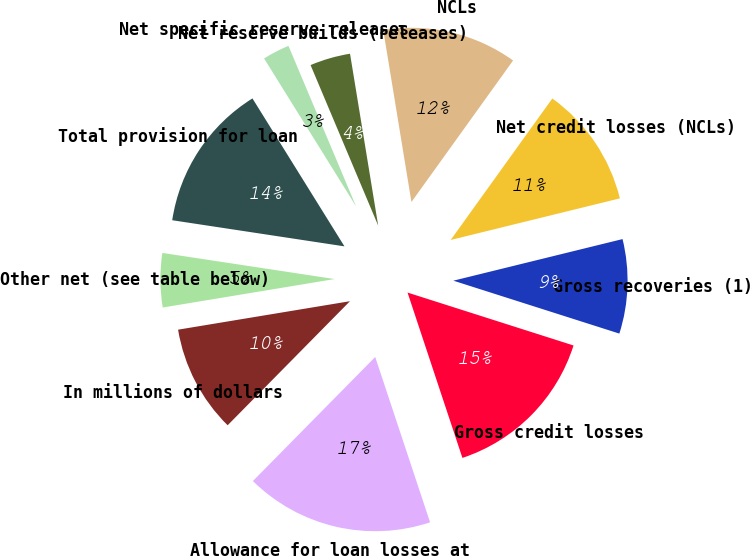<chart> <loc_0><loc_0><loc_500><loc_500><pie_chart><fcel>In millions of dollars<fcel>Allowance for loan losses at<fcel>Gross credit losses<fcel>Gross recoveries (1)<fcel>Net credit losses (NCLs)<fcel>NCLs<fcel>Net reserve builds (releases)<fcel>Net specific reserve releases<fcel>Total provision for loan<fcel>Other net (see table below)<nl><fcel>10.0%<fcel>17.49%<fcel>14.99%<fcel>8.75%<fcel>11.25%<fcel>12.5%<fcel>3.76%<fcel>2.51%<fcel>13.75%<fcel>5.01%<nl></chart> 